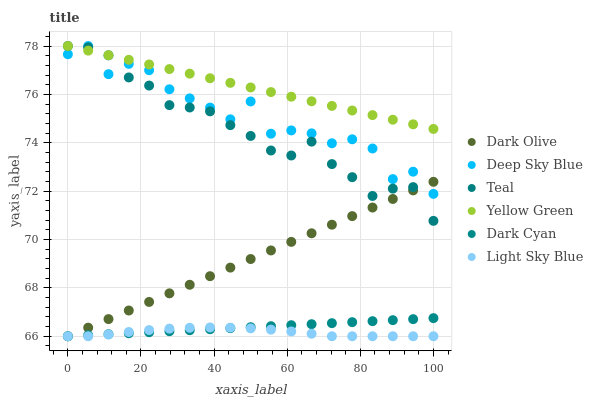Does Light Sky Blue have the minimum area under the curve?
Answer yes or no. Yes. Does Yellow Green have the maximum area under the curve?
Answer yes or no. Yes. Does Dark Olive have the minimum area under the curve?
Answer yes or no. No. Does Dark Olive have the maximum area under the curve?
Answer yes or no. No. Is Yellow Green the smoothest?
Answer yes or no. Yes. Is Deep Sky Blue the roughest?
Answer yes or no. Yes. Is Dark Olive the smoothest?
Answer yes or no. No. Is Dark Olive the roughest?
Answer yes or no. No. Does Dark Olive have the lowest value?
Answer yes or no. Yes. Does Teal have the lowest value?
Answer yes or no. No. Does Yellow Green have the highest value?
Answer yes or no. Yes. Does Dark Olive have the highest value?
Answer yes or no. No. Is Dark Cyan less than Teal?
Answer yes or no. Yes. Is Yellow Green greater than Light Sky Blue?
Answer yes or no. Yes. Does Teal intersect Deep Sky Blue?
Answer yes or no. Yes. Is Teal less than Deep Sky Blue?
Answer yes or no. No. Is Teal greater than Deep Sky Blue?
Answer yes or no. No. Does Dark Cyan intersect Teal?
Answer yes or no. No. 